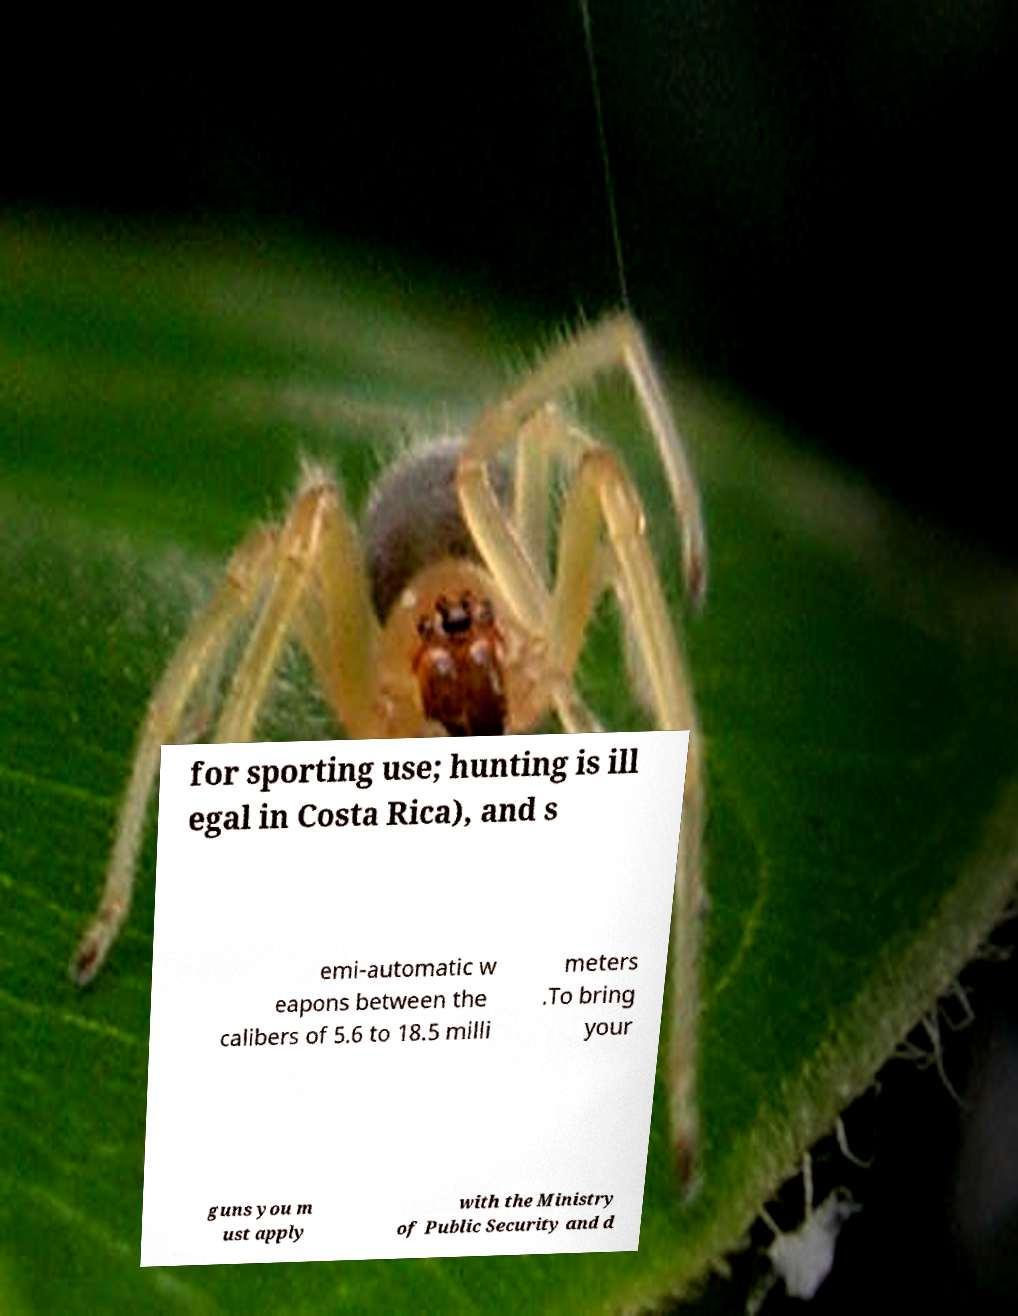Could you extract and type out the text from this image? for sporting use; hunting is ill egal in Costa Rica), and s emi-automatic w eapons between the calibers of 5.6 to 18.5 milli meters .To bring your guns you m ust apply with the Ministry of Public Security and d 